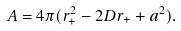Convert formula to latex. <formula><loc_0><loc_0><loc_500><loc_500>A = 4 \pi ( r _ { + } ^ { 2 } - 2 D r _ { + } + a ^ { 2 } ) .</formula> 